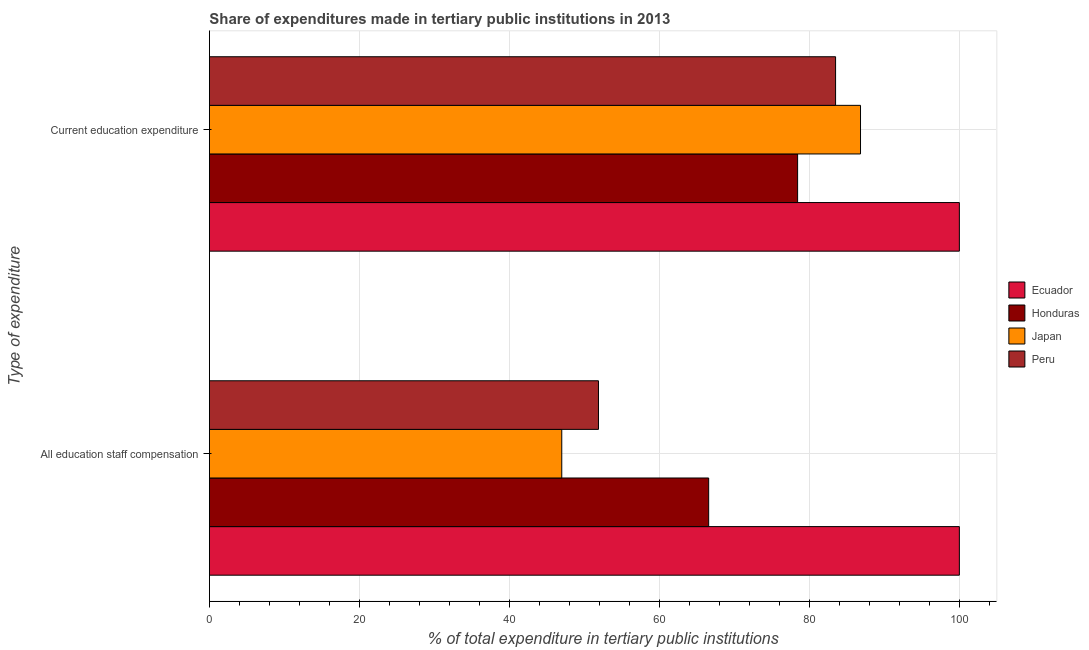How many different coloured bars are there?
Provide a succinct answer. 4. How many groups of bars are there?
Provide a short and direct response. 2. How many bars are there on the 1st tick from the bottom?
Your response must be concise. 4. What is the label of the 2nd group of bars from the top?
Your answer should be very brief. All education staff compensation. What is the expenditure in education in Peru?
Make the answer very short. 83.49. Across all countries, what is the maximum expenditure in staff compensation?
Your answer should be very brief. 100. Across all countries, what is the minimum expenditure in education?
Provide a short and direct response. 78.43. In which country was the expenditure in staff compensation maximum?
Keep it short and to the point. Ecuador. What is the total expenditure in staff compensation in the graph?
Your response must be concise. 265.43. What is the difference between the expenditure in staff compensation in Japan and that in Peru?
Your answer should be compact. -4.89. What is the difference between the expenditure in staff compensation in Peru and the expenditure in education in Ecuador?
Your answer should be very brief. -48.12. What is the average expenditure in staff compensation per country?
Provide a short and direct response. 66.36. What is the difference between the expenditure in education and expenditure in staff compensation in Ecuador?
Ensure brevity in your answer.  0. In how many countries, is the expenditure in staff compensation greater than 56 %?
Keep it short and to the point. 2. What is the ratio of the expenditure in staff compensation in Ecuador to that in Peru?
Keep it short and to the point. 1.93. In how many countries, is the expenditure in education greater than the average expenditure in education taken over all countries?
Your answer should be very brief. 1. What does the 4th bar from the bottom in All education staff compensation represents?
Offer a very short reply. Peru. How many bars are there?
Offer a terse response. 8. Are all the bars in the graph horizontal?
Ensure brevity in your answer.  Yes. What is the difference between two consecutive major ticks on the X-axis?
Your answer should be very brief. 20. Does the graph contain grids?
Your answer should be compact. Yes. Where does the legend appear in the graph?
Offer a very short reply. Center right. How many legend labels are there?
Make the answer very short. 4. What is the title of the graph?
Make the answer very short. Share of expenditures made in tertiary public institutions in 2013. Does "Iraq" appear as one of the legend labels in the graph?
Your answer should be compact. No. What is the label or title of the X-axis?
Keep it short and to the point. % of total expenditure in tertiary public institutions. What is the label or title of the Y-axis?
Your response must be concise. Type of expenditure. What is the % of total expenditure in tertiary public institutions of Honduras in All education staff compensation?
Keep it short and to the point. 66.57. What is the % of total expenditure in tertiary public institutions in Japan in All education staff compensation?
Keep it short and to the point. 46.98. What is the % of total expenditure in tertiary public institutions of Peru in All education staff compensation?
Your answer should be compact. 51.88. What is the % of total expenditure in tertiary public institutions in Ecuador in Current education expenditure?
Your answer should be compact. 100. What is the % of total expenditure in tertiary public institutions of Honduras in Current education expenditure?
Your response must be concise. 78.43. What is the % of total expenditure in tertiary public institutions of Japan in Current education expenditure?
Keep it short and to the point. 86.82. What is the % of total expenditure in tertiary public institutions of Peru in Current education expenditure?
Offer a terse response. 83.49. Across all Type of expenditure, what is the maximum % of total expenditure in tertiary public institutions in Ecuador?
Offer a terse response. 100. Across all Type of expenditure, what is the maximum % of total expenditure in tertiary public institutions of Honduras?
Offer a terse response. 78.43. Across all Type of expenditure, what is the maximum % of total expenditure in tertiary public institutions of Japan?
Keep it short and to the point. 86.82. Across all Type of expenditure, what is the maximum % of total expenditure in tertiary public institutions of Peru?
Provide a succinct answer. 83.49. Across all Type of expenditure, what is the minimum % of total expenditure in tertiary public institutions in Honduras?
Make the answer very short. 66.57. Across all Type of expenditure, what is the minimum % of total expenditure in tertiary public institutions in Japan?
Your response must be concise. 46.98. Across all Type of expenditure, what is the minimum % of total expenditure in tertiary public institutions of Peru?
Your response must be concise. 51.88. What is the total % of total expenditure in tertiary public institutions in Honduras in the graph?
Your answer should be very brief. 145. What is the total % of total expenditure in tertiary public institutions in Japan in the graph?
Give a very brief answer. 133.8. What is the total % of total expenditure in tertiary public institutions of Peru in the graph?
Your answer should be very brief. 135.37. What is the difference between the % of total expenditure in tertiary public institutions in Honduras in All education staff compensation and that in Current education expenditure?
Offer a very short reply. -11.86. What is the difference between the % of total expenditure in tertiary public institutions of Japan in All education staff compensation and that in Current education expenditure?
Keep it short and to the point. -39.84. What is the difference between the % of total expenditure in tertiary public institutions in Peru in All education staff compensation and that in Current education expenditure?
Your response must be concise. -31.62. What is the difference between the % of total expenditure in tertiary public institutions of Ecuador in All education staff compensation and the % of total expenditure in tertiary public institutions of Honduras in Current education expenditure?
Make the answer very short. 21.57. What is the difference between the % of total expenditure in tertiary public institutions in Ecuador in All education staff compensation and the % of total expenditure in tertiary public institutions in Japan in Current education expenditure?
Your response must be concise. 13.18. What is the difference between the % of total expenditure in tertiary public institutions of Ecuador in All education staff compensation and the % of total expenditure in tertiary public institutions of Peru in Current education expenditure?
Offer a terse response. 16.51. What is the difference between the % of total expenditure in tertiary public institutions in Honduras in All education staff compensation and the % of total expenditure in tertiary public institutions in Japan in Current education expenditure?
Provide a succinct answer. -20.25. What is the difference between the % of total expenditure in tertiary public institutions of Honduras in All education staff compensation and the % of total expenditure in tertiary public institutions of Peru in Current education expenditure?
Give a very brief answer. -16.92. What is the difference between the % of total expenditure in tertiary public institutions in Japan in All education staff compensation and the % of total expenditure in tertiary public institutions in Peru in Current education expenditure?
Your answer should be compact. -36.51. What is the average % of total expenditure in tertiary public institutions in Honduras per Type of expenditure?
Your answer should be compact. 72.5. What is the average % of total expenditure in tertiary public institutions in Japan per Type of expenditure?
Your response must be concise. 66.9. What is the average % of total expenditure in tertiary public institutions in Peru per Type of expenditure?
Make the answer very short. 67.69. What is the difference between the % of total expenditure in tertiary public institutions of Ecuador and % of total expenditure in tertiary public institutions of Honduras in All education staff compensation?
Your response must be concise. 33.43. What is the difference between the % of total expenditure in tertiary public institutions of Ecuador and % of total expenditure in tertiary public institutions of Japan in All education staff compensation?
Your answer should be very brief. 53.02. What is the difference between the % of total expenditure in tertiary public institutions in Ecuador and % of total expenditure in tertiary public institutions in Peru in All education staff compensation?
Your response must be concise. 48.12. What is the difference between the % of total expenditure in tertiary public institutions of Honduras and % of total expenditure in tertiary public institutions of Japan in All education staff compensation?
Ensure brevity in your answer.  19.59. What is the difference between the % of total expenditure in tertiary public institutions in Honduras and % of total expenditure in tertiary public institutions in Peru in All education staff compensation?
Your answer should be very brief. 14.69. What is the difference between the % of total expenditure in tertiary public institutions of Japan and % of total expenditure in tertiary public institutions of Peru in All education staff compensation?
Keep it short and to the point. -4.89. What is the difference between the % of total expenditure in tertiary public institutions of Ecuador and % of total expenditure in tertiary public institutions of Honduras in Current education expenditure?
Ensure brevity in your answer.  21.57. What is the difference between the % of total expenditure in tertiary public institutions of Ecuador and % of total expenditure in tertiary public institutions of Japan in Current education expenditure?
Keep it short and to the point. 13.18. What is the difference between the % of total expenditure in tertiary public institutions in Ecuador and % of total expenditure in tertiary public institutions in Peru in Current education expenditure?
Ensure brevity in your answer.  16.51. What is the difference between the % of total expenditure in tertiary public institutions in Honduras and % of total expenditure in tertiary public institutions in Japan in Current education expenditure?
Keep it short and to the point. -8.39. What is the difference between the % of total expenditure in tertiary public institutions of Honduras and % of total expenditure in tertiary public institutions of Peru in Current education expenditure?
Your answer should be compact. -5.06. What is the difference between the % of total expenditure in tertiary public institutions of Japan and % of total expenditure in tertiary public institutions of Peru in Current education expenditure?
Your answer should be very brief. 3.33. What is the ratio of the % of total expenditure in tertiary public institutions of Ecuador in All education staff compensation to that in Current education expenditure?
Ensure brevity in your answer.  1. What is the ratio of the % of total expenditure in tertiary public institutions of Honduras in All education staff compensation to that in Current education expenditure?
Provide a short and direct response. 0.85. What is the ratio of the % of total expenditure in tertiary public institutions of Japan in All education staff compensation to that in Current education expenditure?
Your response must be concise. 0.54. What is the ratio of the % of total expenditure in tertiary public institutions of Peru in All education staff compensation to that in Current education expenditure?
Provide a succinct answer. 0.62. What is the difference between the highest and the second highest % of total expenditure in tertiary public institutions in Ecuador?
Your answer should be very brief. 0. What is the difference between the highest and the second highest % of total expenditure in tertiary public institutions of Honduras?
Provide a succinct answer. 11.86. What is the difference between the highest and the second highest % of total expenditure in tertiary public institutions of Japan?
Your response must be concise. 39.84. What is the difference between the highest and the second highest % of total expenditure in tertiary public institutions in Peru?
Offer a terse response. 31.62. What is the difference between the highest and the lowest % of total expenditure in tertiary public institutions in Ecuador?
Your response must be concise. 0. What is the difference between the highest and the lowest % of total expenditure in tertiary public institutions of Honduras?
Provide a short and direct response. 11.86. What is the difference between the highest and the lowest % of total expenditure in tertiary public institutions of Japan?
Make the answer very short. 39.84. What is the difference between the highest and the lowest % of total expenditure in tertiary public institutions of Peru?
Offer a very short reply. 31.62. 